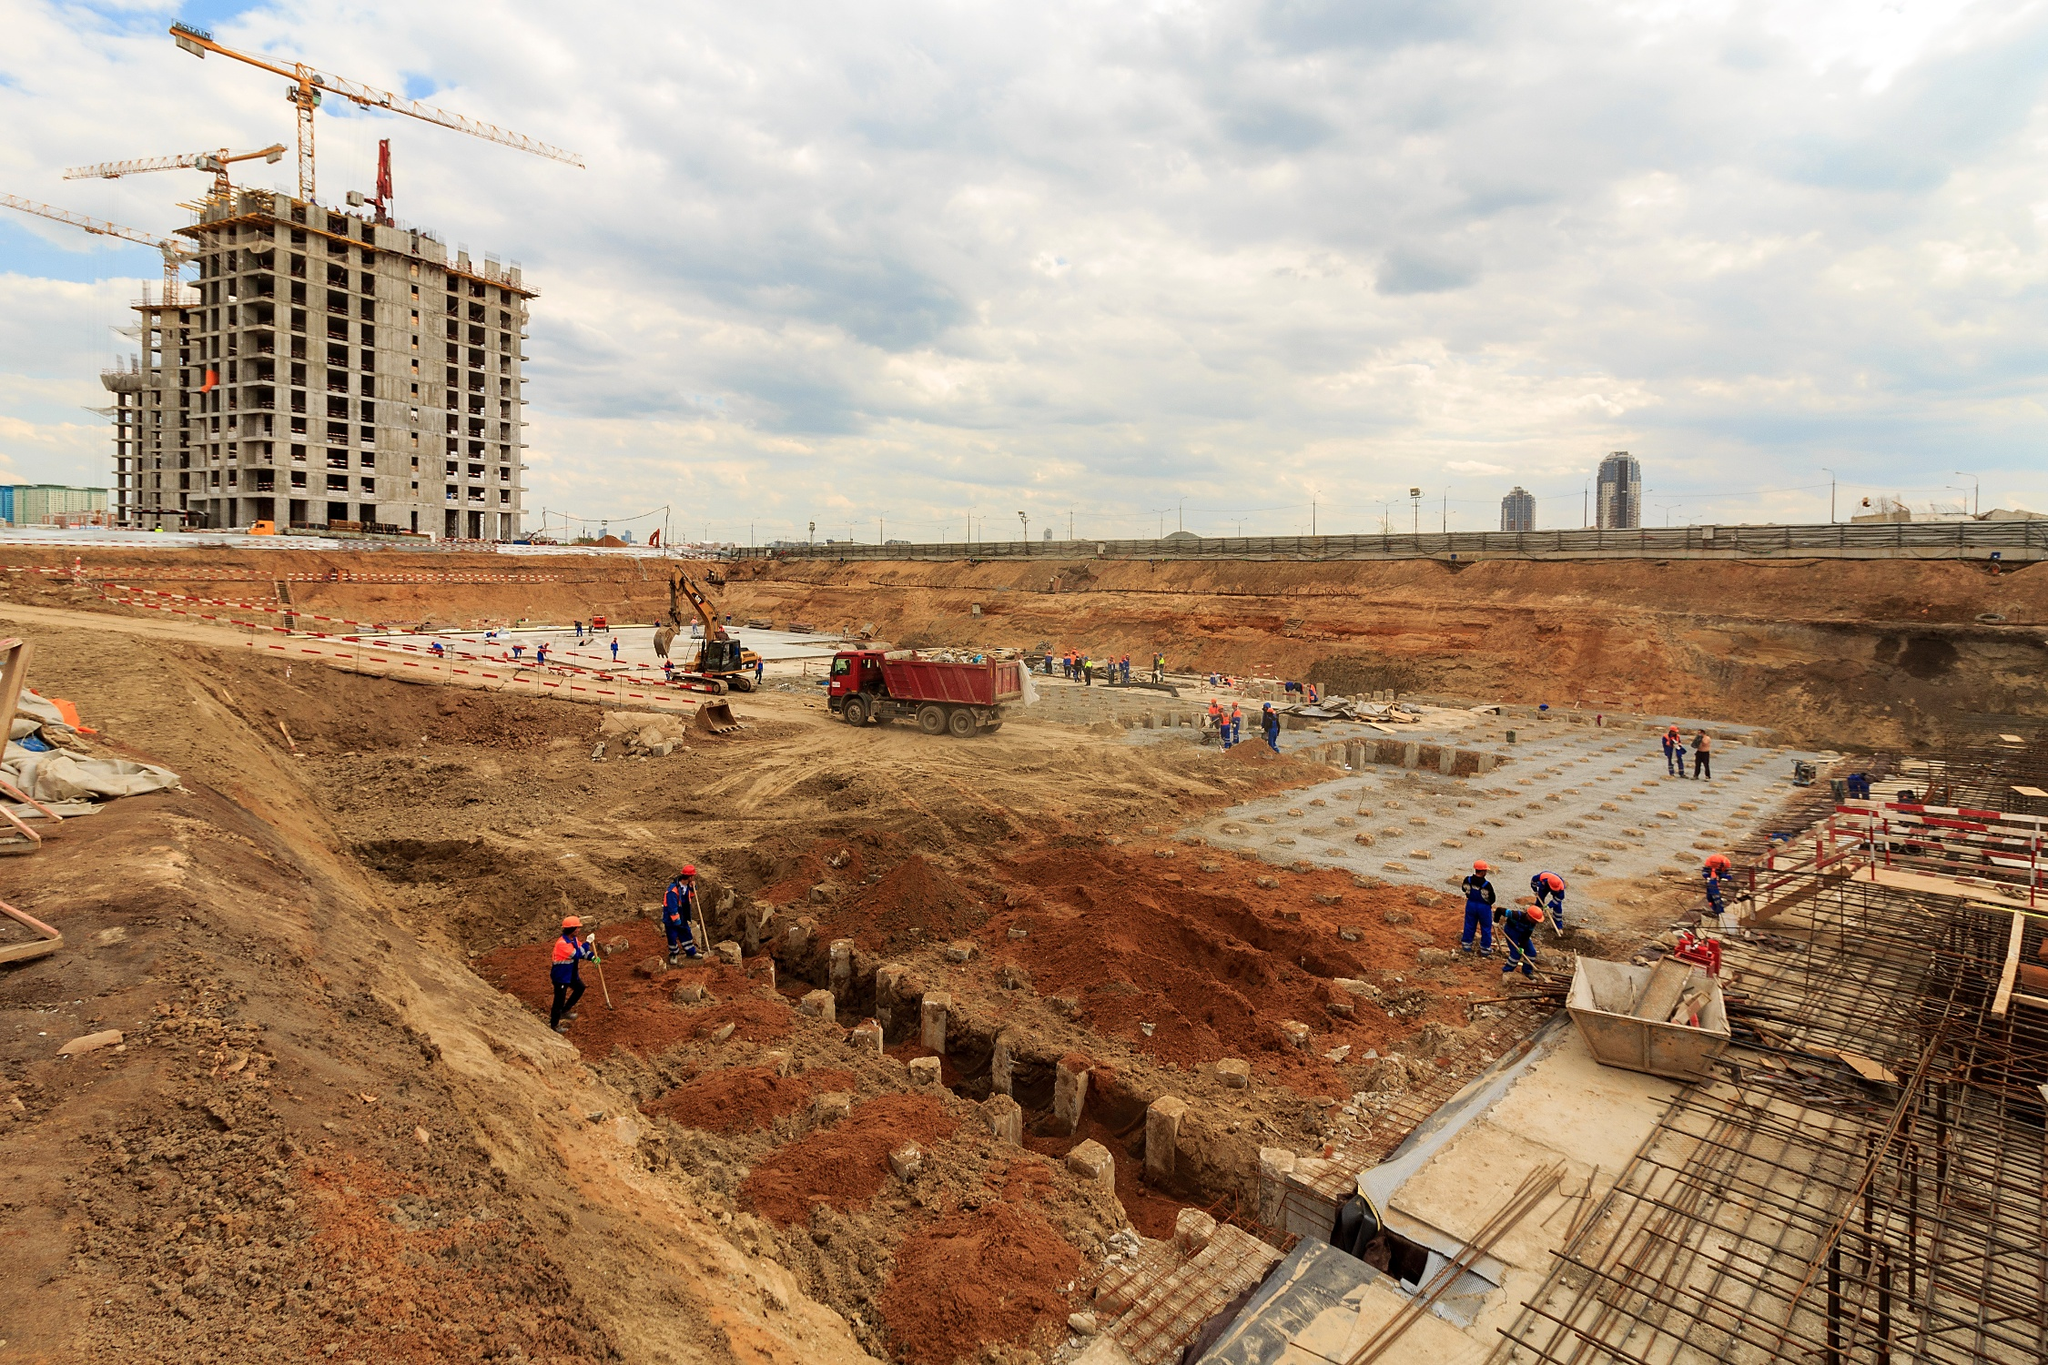What challenges do the workers face at this stage of construction? At this stage of construction, the workers primarily face challenges related to the foundational work. Ensuring the ground is stable and properly prepared is crucial, as any errors can affect the building's long-term integrity. There are also logistical hurdles in managing heavy machinery, like bulldozers and cranes, which require careful coordination to avoid accidents. Additionally, working in potentially inclement weather can pose safety risks and slow progress. Can you describe the tools and machinery visible at the site? Certainly! The site features a variety of tools and machinery essential for construction. A prominent crane stands atop the main building, used for lifting heavy materials to higher floors. Closer to the workers, small hand tools such as shovels and picks are visible, used for digging and shaping the foundation. Additionally, a bulldozer is parked on-site, intended for moving large quantities of earth, and a dump truck appears ready to transport debris or materials. 